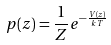Convert formula to latex. <formula><loc_0><loc_0><loc_500><loc_500>p ( z ) = \frac { 1 } { Z } e ^ { - \frac { V ( z ) } { k T } }</formula> 